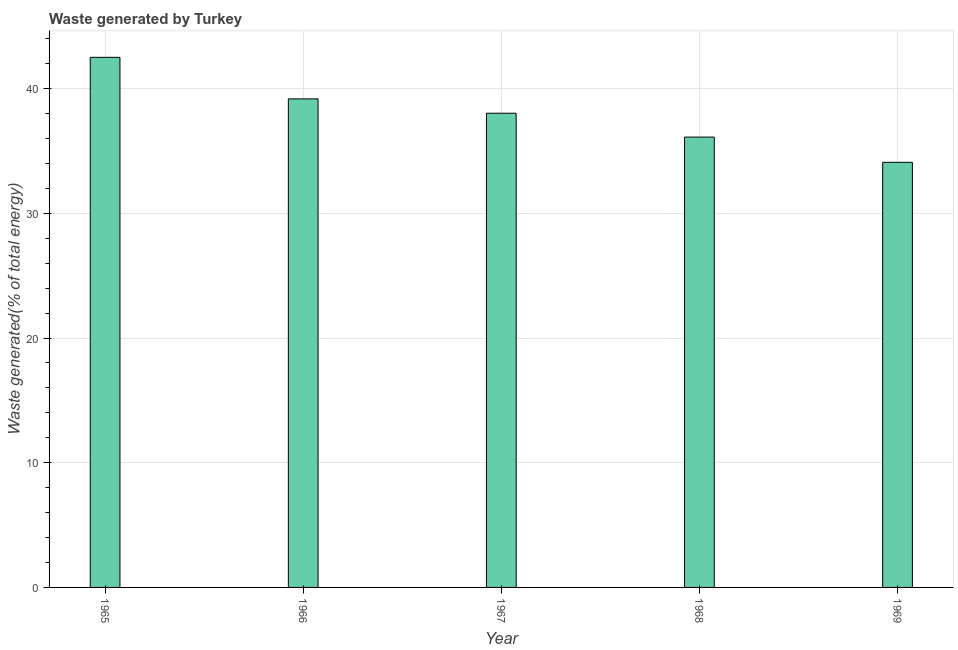What is the title of the graph?
Give a very brief answer. Waste generated by Turkey. What is the label or title of the Y-axis?
Your answer should be compact. Waste generated(% of total energy). What is the amount of waste generated in 1967?
Keep it short and to the point. 38.03. Across all years, what is the maximum amount of waste generated?
Offer a terse response. 42.51. Across all years, what is the minimum amount of waste generated?
Your answer should be very brief. 34.09. In which year was the amount of waste generated maximum?
Provide a succinct answer. 1965. In which year was the amount of waste generated minimum?
Offer a very short reply. 1969. What is the sum of the amount of waste generated?
Provide a succinct answer. 189.91. What is the difference between the amount of waste generated in 1967 and 1968?
Provide a short and direct response. 1.91. What is the average amount of waste generated per year?
Offer a very short reply. 37.98. What is the median amount of waste generated?
Your response must be concise. 38.03. In how many years, is the amount of waste generated greater than 8 %?
Give a very brief answer. 5. What is the ratio of the amount of waste generated in 1966 to that in 1967?
Offer a terse response. 1.03. Is the amount of waste generated in 1965 less than that in 1968?
Your response must be concise. No. What is the difference between the highest and the second highest amount of waste generated?
Provide a succinct answer. 3.33. Is the sum of the amount of waste generated in 1965 and 1967 greater than the maximum amount of waste generated across all years?
Offer a very short reply. Yes. What is the difference between the highest and the lowest amount of waste generated?
Ensure brevity in your answer.  8.42. In how many years, is the amount of waste generated greater than the average amount of waste generated taken over all years?
Offer a terse response. 3. How many years are there in the graph?
Make the answer very short. 5. What is the difference between two consecutive major ticks on the Y-axis?
Keep it short and to the point. 10. Are the values on the major ticks of Y-axis written in scientific E-notation?
Make the answer very short. No. What is the Waste generated(% of total energy) in 1965?
Offer a terse response. 42.51. What is the Waste generated(% of total energy) in 1966?
Your answer should be very brief. 39.18. What is the Waste generated(% of total energy) of 1967?
Ensure brevity in your answer.  38.03. What is the Waste generated(% of total energy) of 1968?
Your answer should be very brief. 36.11. What is the Waste generated(% of total energy) of 1969?
Give a very brief answer. 34.09. What is the difference between the Waste generated(% of total energy) in 1965 and 1966?
Offer a very short reply. 3.33. What is the difference between the Waste generated(% of total energy) in 1965 and 1967?
Keep it short and to the point. 4.48. What is the difference between the Waste generated(% of total energy) in 1965 and 1968?
Your answer should be compact. 6.4. What is the difference between the Waste generated(% of total energy) in 1965 and 1969?
Offer a terse response. 8.42. What is the difference between the Waste generated(% of total energy) in 1966 and 1967?
Your answer should be very brief. 1.15. What is the difference between the Waste generated(% of total energy) in 1966 and 1968?
Keep it short and to the point. 3.06. What is the difference between the Waste generated(% of total energy) in 1966 and 1969?
Keep it short and to the point. 5.09. What is the difference between the Waste generated(% of total energy) in 1967 and 1968?
Give a very brief answer. 1.91. What is the difference between the Waste generated(% of total energy) in 1967 and 1969?
Your answer should be very brief. 3.94. What is the difference between the Waste generated(% of total energy) in 1968 and 1969?
Offer a terse response. 2.02. What is the ratio of the Waste generated(% of total energy) in 1965 to that in 1966?
Offer a terse response. 1.08. What is the ratio of the Waste generated(% of total energy) in 1965 to that in 1967?
Provide a succinct answer. 1.12. What is the ratio of the Waste generated(% of total energy) in 1965 to that in 1968?
Your response must be concise. 1.18. What is the ratio of the Waste generated(% of total energy) in 1965 to that in 1969?
Give a very brief answer. 1.25. What is the ratio of the Waste generated(% of total energy) in 1966 to that in 1968?
Offer a very short reply. 1.08. What is the ratio of the Waste generated(% of total energy) in 1966 to that in 1969?
Offer a very short reply. 1.15. What is the ratio of the Waste generated(% of total energy) in 1967 to that in 1968?
Your answer should be compact. 1.05. What is the ratio of the Waste generated(% of total energy) in 1967 to that in 1969?
Offer a very short reply. 1.11. What is the ratio of the Waste generated(% of total energy) in 1968 to that in 1969?
Offer a very short reply. 1.06. 